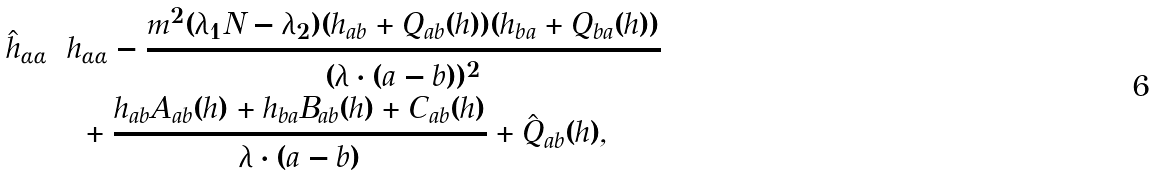<formula> <loc_0><loc_0><loc_500><loc_500>\hat { h } _ { \alpha \alpha } & = h _ { \alpha \alpha } - \frac { m ^ { 2 } ( \lambda _ { 1 } N - \lambda _ { 2 } ) ( h _ { a b } + Q _ { a b } ( h ) ) ( h _ { b a } + Q _ { b a } ( h ) ) } { ( \lambda \cdot ( a - b ) ) ^ { 2 } } \\ & \quad + \frac { h _ { a b } A _ { a b } ( h ) + h _ { b a } B _ { a b } ( h ) + C _ { a b } ( h ) } { \lambda \cdot ( a - b ) } + \hat { Q } _ { a b } ( h ) ,</formula> 